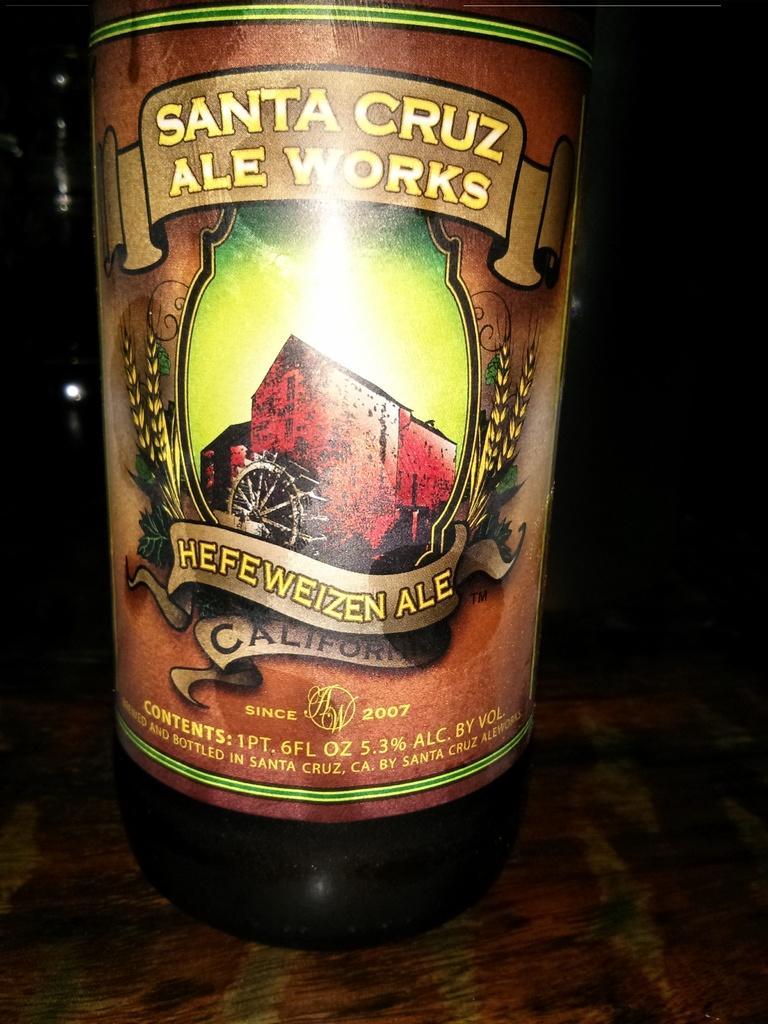Can you describe this image briefly? In this picture we can see a sticker to a bottle and the bottle is on an object. Behind the bottle, there is a dark background. 